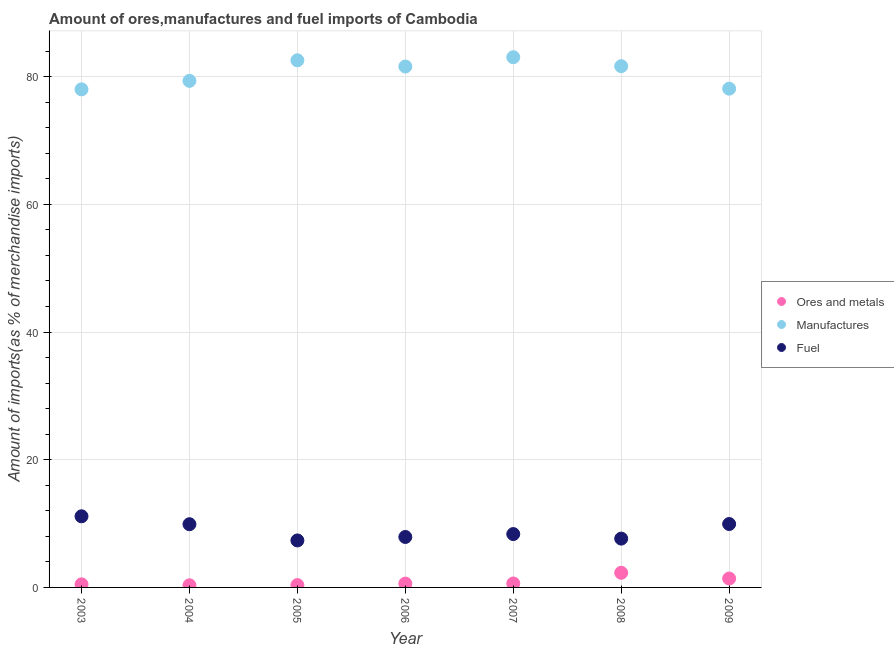How many different coloured dotlines are there?
Make the answer very short. 3. What is the percentage of fuel imports in 2005?
Your response must be concise. 7.36. Across all years, what is the maximum percentage of fuel imports?
Provide a short and direct response. 11.14. Across all years, what is the minimum percentage of manufactures imports?
Keep it short and to the point. 78.02. In which year was the percentage of manufactures imports maximum?
Provide a short and direct response. 2007. In which year was the percentage of fuel imports minimum?
Make the answer very short. 2005. What is the total percentage of fuel imports in the graph?
Your answer should be compact. 62.24. What is the difference between the percentage of ores and metals imports in 2003 and that in 2004?
Your response must be concise. 0.15. What is the difference between the percentage of manufactures imports in 2003 and the percentage of ores and metals imports in 2005?
Provide a short and direct response. 77.65. What is the average percentage of fuel imports per year?
Your answer should be compact. 8.89. In the year 2003, what is the difference between the percentage of manufactures imports and percentage of fuel imports?
Provide a short and direct response. 66.88. In how many years, is the percentage of fuel imports greater than 24 %?
Provide a short and direct response. 0. What is the ratio of the percentage of ores and metals imports in 2003 to that in 2004?
Offer a terse response. 1.44. Is the percentage of fuel imports in 2005 less than that in 2008?
Provide a succinct answer. Yes. Is the difference between the percentage of ores and metals imports in 2006 and 2007 greater than the difference between the percentage of fuel imports in 2006 and 2007?
Your response must be concise. Yes. What is the difference between the highest and the second highest percentage of manufactures imports?
Your response must be concise. 0.48. What is the difference between the highest and the lowest percentage of fuel imports?
Keep it short and to the point. 3.78. In how many years, is the percentage of manufactures imports greater than the average percentage of manufactures imports taken over all years?
Offer a terse response. 4. Is the sum of the percentage of fuel imports in 2004 and 2007 greater than the maximum percentage of ores and metals imports across all years?
Your answer should be very brief. Yes. Is it the case that in every year, the sum of the percentage of ores and metals imports and percentage of manufactures imports is greater than the percentage of fuel imports?
Give a very brief answer. Yes. Does the percentage of manufactures imports monotonically increase over the years?
Provide a short and direct response. No. Is the percentage of ores and metals imports strictly greater than the percentage of manufactures imports over the years?
Keep it short and to the point. No. Is the percentage of ores and metals imports strictly less than the percentage of fuel imports over the years?
Give a very brief answer. Yes. How many dotlines are there?
Give a very brief answer. 3. What is the difference between two consecutive major ticks on the Y-axis?
Make the answer very short. 20. Does the graph contain any zero values?
Your answer should be compact. No. How many legend labels are there?
Provide a succinct answer. 3. What is the title of the graph?
Your response must be concise. Amount of ores,manufactures and fuel imports of Cambodia. What is the label or title of the Y-axis?
Provide a succinct answer. Amount of imports(as % of merchandise imports). What is the Amount of imports(as % of merchandise imports) of Ores and metals in 2003?
Keep it short and to the point. 0.49. What is the Amount of imports(as % of merchandise imports) of Manufactures in 2003?
Your answer should be compact. 78.02. What is the Amount of imports(as % of merchandise imports) in Fuel in 2003?
Offer a terse response. 11.14. What is the Amount of imports(as % of merchandise imports) of Ores and metals in 2004?
Your response must be concise. 0.34. What is the Amount of imports(as % of merchandise imports) in Manufactures in 2004?
Offer a terse response. 79.35. What is the Amount of imports(as % of merchandise imports) of Fuel in 2004?
Ensure brevity in your answer.  9.9. What is the Amount of imports(as % of merchandise imports) of Ores and metals in 2005?
Your answer should be compact. 0.37. What is the Amount of imports(as % of merchandise imports) of Manufactures in 2005?
Offer a terse response. 82.57. What is the Amount of imports(as % of merchandise imports) of Fuel in 2005?
Provide a short and direct response. 7.36. What is the Amount of imports(as % of merchandise imports) in Ores and metals in 2006?
Offer a very short reply. 0.6. What is the Amount of imports(as % of merchandise imports) in Manufactures in 2006?
Ensure brevity in your answer.  81.6. What is the Amount of imports(as % of merchandise imports) of Fuel in 2006?
Your answer should be compact. 7.9. What is the Amount of imports(as % of merchandise imports) of Ores and metals in 2007?
Keep it short and to the point. 0.62. What is the Amount of imports(as % of merchandise imports) in Manufactures in 2007?
Provide a succinct answer. 83.05. What is the Amount of imports(as % of merchandise imports) of Fuel in 2007?
Keep it short and to the point. 8.36. What is the Amount of imports(as % of merchandise imports) of Ores and metals in 2008?
Make the answer very short. 2.29. What is the Amount of imports(as % of merchandise imports) of Manufactures in 2008?
Provide a succinct answer. 81.65. What is the Amount of imports(as % of merchandise imports) in Fuel in 2008?
Keep it short and to the point. 7.65. What is the Amount of imports(as % of merchandise imports) of Ores and metals in 2009?
Provide a short and direct response. 1.4. What is the Amount of imports(as % of merchandise imports) of Manufactures in 2009?
Your answer should be very brief. 78.13. What is the Amount of imports(as % of merchandise imports) in Fuel in 2009?
Provide a short and direct response. 9.93. Across all years, what is the maximum Amount of imports(as % of merchandise imports) of Ores and metals?
Offer a very short reply. 2.29. Across all years, what is the maximum Amount of imports(as % of merchandise imports) in Manufactures?
Your answer should be very brief. 83.05. Across all years, what is the maximum Amount of imports(as % of merchandise imports) of Fuel?
Your answer should be compact. 11.14. Across all years, what is the minimum Amount of imports(as % of merchandise imports) of Ores and metals?
Your response must be concise. 0.34. Across all years, what is the minimum Amount of imports(as % of merchandise imports) of Manufactures?
Your answer should be compact. 78.02. Across all years, what is the minimum Amount of imports(as % of merchandise imports) in Fuel?
Give a very brief answer. 7.36. What is the total Amount of imports(as % of merchandise imports) of Ores and metals in the graph?
Offer a terse response. 6.1. What is the total Amount of imports(as % of merchandise imports) in Manufactures in the graph?
Keep it short and to the point. 564.35. What is the total Amount of imports(as % of merchandise imports) in Fuel in the graph?
Offer a terse response. 62.24. What is the difference between the Amount of imports(as % of merchandise imports) in Ores and metals in 2003 and that in 2004?
Your answer should be compact. 0.15. What is the difference between the Amount of imports(as % of merchandise imports) of Manufactures in 2003 and that in 2004?
Your answer should be compact. -1.33. What is the difference between the Amount of imports(as % of merchandise imports) of Fuel in 2003 and that in 2004?
Provide a succinct answer. 1.24. What is the difference between the Amount of imports(as % of merchandise imports) in Ores and metals in 2003 and that in 2005?
Your response must be concise. 0.12. What is the difference between the Amount of imports(as % of merchandise imports) in Manufactures in 2003 and that in 2005?
Provide a succinct answer. -4.55. What is the difference between the Amount of imports(as % of merchandise imports) of Fuel in 2003 and that in 2005?
Your answer should be very brief. 3.78. What is the difference between the Amount of imports(as % of merchandise imports) of Ores and metals in 2003 and that in 2006?
Offer a very short reply. -0.12. What is the difference between the Amount of imports(as % of merchandise imports) of Manufactures in 2003 and that in 2006?
Your answer should be compact. -3.58. What is the difference between the Amount of imports(as % of merchandise imports) of Fuel in 2003 and that in 2006?
Make the answer very short. 3.24. What is the difference between the Amount of imports(as % of merchandise imports) in Ores and metals in 2003 and that in 2007?
Keep it short and to the point. -0.14. What is the difference between the Amount of imports(as % of merchandise imports) of Manufactures in 2003 and that in 2007?
Your answer should be very brief. -5.03. What is the difference between the Amount of imports(as % of merchandise imports) of Fuel in 2003 and that in 2007?
Your response must be concise. 2.78. What is the difference between the Amount of imports(as % of merchandise imports) of Ores and metals in 2003 and that in 2008?
Offer a terse response. -1.81. What is the difference between the Amount of imports(as % of merchandise imports) in Manufactures in 2003 and that in 2008?
Provide a succinct answer. -3.63. What is the difference between the Amount of imports(as % of merchandise imports) in Fuel in 2003 and that in 2008?
Offer a terse response. 3.5. What is the difference between the Amount of imports(as % of merchandise imports) in Ores and metals in 2003 and that in 2009?
Your answer should be very brief. -0.91. What is the difference between the Amount of imports(as % of merchandise imports) of Manufactures in 2003 and that in 2009?
Provide a short and direct response. -0.11. What is the difference between the Amount of imports(as % of merchandise imports) in Fuel in 2003 and that in 2009?
Your answer should be compact. 1.21. What is the difference between the Amount of imports(as % of merchandise imports) of Ores and metals in 2004 and that in 2005?
Offer a terse response. -0.03. What is the difference between the Amount of imports(as % of merchandise imports) of Manufactures in 2004 and that in 2005?
Your answer should be compact. -3.22. What is the difference between the Amount of imports(as % of merchandise imports) in Fuel in 2004 and that in 2005?
Offer a terse response. 2.54. What is the difference between the Amount of imports(as % of merchandise imports) in Ores and metals in 2004 and that in 2006?
Offer a terse response. -0.26. What is the difference between the Amount of imports(as % of merchandise imports) of Manufactures in 2004 and that in 2006?
Provide a short and direct response. -2.25. What is the difference between the Amount of imports(as % of merchandise imports) of Fuel in 2004 and that in 2006?
Make the answer very short. 2. What is the difference between the Amount of imports(as % of merchandise imports) in Ores and metals in 2004 and that in 2007?
Your response must be concise. -0.28. What is the difference between the Amount of imports(as % of merchandise imports) in Manufactures in 2004 and that in 2007?
Your answer should be compact. -3.7. What is the difference between the Amount of imports(as % of merchandise imports) of Fuel in 2004 and that in 2007?
Provide a short and direct response. 1.54. What is the difference between the Amount of imports(as % of merchandise imports) of Ores and metals in 2004 and that in 2008?
Ensure brevity in your answer.  -1.96. What is the difference between the Amount of imports(as % of merchandise imports) of Manufactures in 2004 and that in 2008?
Ensure brevity in your answer.  -2.3. What is the difference between the Amount of imports(as % of merchandise imports) of Fuel in 2004 and that in 2008?
Offer a terse response. 2.25. What is the difference between the Amount of imports(as % of merchandise imports) in Ores and metals in 2004 and that in 2009?
Your answer should be very brief. -1.06. What is the difference between the Amount of imports(as % of merchandise imports) of Manufactures in 2004 and that in 2009?
Ensure brevity in your answer.  1.22. What is the difference between the Amount of imports(as % of merchandise imports) in Fuel in 2004 and that in 2009?
Ensure brevity in your answer.  -0.03. What is the difference between the Amount of imports(as % of merchandise imports) in Ores and metals in 2005 and that in 2006?
Provide a succinct answer. -0.24. What is the difference between the Amount of imports(as % of merchandise imports) in Manufactures in 2005 and that in 2006?
Offer a terse response. 0.97. What is the difference between the Amount of imports(as % of merchandise imports) in Fuel in 2005 and that in 2006?
Offer a terse response. -0.55. What is the difference between the Amount of imports(as % of merchandise imports) of Ores and metals in 2005 and that in 2007?
Offer a very short reply. -0.25. What is the difference between the Amount of imports(as % of merchandise imports) of Manufactures in 2005 and that in 2007?
Your answer should be very brief. -0.48. What is the difference between the Amount of imports(as % of merchandise imports) of Fuel in 2005 and that in 2007?
Your answer should be very brief. -1. What is the difference between the Amount of imports(as % of merchandise imports) of Ores and metals in 2005 and that in 2008?
Your answer should be very brief. -1.93. What is the difference between the Amount of imports(as % of merchandise imports) in Manufactures in 2005 and that in 2008?
Provide a succinct answer. 0.92. What is the difference between the Amount of imports(as % of merchandise imports) in Fuel in 2005 and that in 2008?
Provide a short and direct response. -0.29. What is the difference between the Amount of imports(as % of merchandise imports) in Ores and metals in 2005 and that in 2009?
Your answer should be very brief. -1.03. What is the difference between the Amount of imports(as % of merchandise imports) in Manufactures in 2005 and that in 2009?
Ensure brevity in your answer.  4.44. What is the difference between the Amount of imports(as % of merchandise imports) of Fuel in 2005 and that in 2009?
Your answer should be very brief. -2.57. What is the difference between the Amount of imports(as % of merchandise imports) of Ores and metals in 2006 and that in 2007?
Provide a short and direct response. -0.02. What is the difference between the Amount of imports(as % of merchandise imports) in Manufactures in 2006 and that in 2007?
Your response must be concise. -1.46. What is the difference between the Amount of imports(as % of merchandise imports) of Fuel in 2006 and that in 2007?
Your answer should be compact. -0.45. What is the difference between the Amount of imports(as % of merchandise imports) in Ores and metals in 2006 and that in 2008?
Your answer should be very brief. -1.69. What is the difference between the Amount of imports(as % of merchandise imports) of Manufactures in 2006 and that in 2008?
Offer a terse response. -0.05. What is the difference between the Amount of imports(as % of merchandise imports) in Fuel in 2006 and that in 2008?
Provide a succinct answer. 0.26. What is the difference between the Amount of imports(as % of merchandise imports) of Ores and metals in 2006 and that in 2009?
Offer a very short reply. -0.8. What is the difference between the Amount of imports(as % of merchandise imports) in Manufactures in 2006 and that in 2009?
Make the answer very short. 3.47. What is the difference between the Amount of imports(as % of merchandise imports) of Fuel in 2006 and that in 2009?
Your response must be concise. -2.03. What is the difference between the Amount of imports(as % of merchandise imports) of Ores and metals in 2007 and that in 2008?
Keep it short and to the point. -1.67. What is the difference between the Amount of imports(as % of merchandise imports) of Manufactures in 2007 and that in 2008?
Provide a short and direct response. 1.4. What is the difference between the Amount of imports(as % of merchandise imports) in Fuel in 2007 and that in 2008?
Your response must be concise. 0.71. What is the difference between the Amount of imports(as % of merchandise imports) in Ores and metals in 2007 and that in 2009?
Offer a terse response. -0.78. What is the difference between the Amount of imports(as % of merchandise imports) of Manufactures in 2007 and that in 2009?
Your answer should be compact. 4.92. What is the difference between the Amount of imports(as % of merchandise imports) in Fuel in 2007 and that in 2009?
Your answer should be very brief. -1.57. What is the difference between the Amount of imports(as % of merchandise imports) in Ores and metals in 2008 and that in 2009?
Give a very brief answer. 0.89. What is the difference between the Amount of imports(as % of merchandise imports) of Manufactures in 2008 and that in 2009?
Keep it short and to the point. 3.52. What is the difference between the Amount of imports(as % of merchandise imports) of Fuel in 2008 and that in 2009?
Offer a very short reply. -2.29. What is the difference between the Amount of imports(as % of merchandise imports) of Ores and metals in 2003 and the Amount of imports(as % of merchandise imports) of Manufactures in 2004?
Offer a very short reply. -78.86. What is the difference between the Amount of imports(as % of merchandise imports) in Ores and metals in 2003 and the Amount of imports(as % of merchandise imports) in Fuel in 2004?
Your answer should be compact. -9.42. What is the difference between the Amount of imports(as % of merchandise imports) in Manufactures in 2003 and the Amount of imports(as % of merchandise imports) in Fuel in 2004?
Ensure brevity in your answer.  68.12. What is the difference between the Amount of imports(as % of merchandise imports) in Ores and metals in 2003 and the Amount of imports(as % of merchandise imports) in Manufactures in 2005?
Give a very brief answer. -82.08. What is the difference between the Amount of imports(as % of merchandise imports) of Ores and metals in 2003 and the Amount of imports(as % of merchandise imports) of Fuel in 2005?
Your answer should be compact. -6.87. What is the difference between the Amount of imports(as % of merchandise imports) of Manufactures in 2003 and the Amount of imports(as % of merchandise imports) of Fuel in 2005?
Your response must be concise. 70.66. What is the difference between the Amount of imports(as % of merchandise imports) of Ores and metals in 2003 and the Amount of imports(as % of merchandise imports) of Manufactures in 2006?
Offer a very short reply. -81.11. What is the difference between the Amount of imports(as % of merchandise imports) in Ores and metals in 2003 and the Amount of imports(as % of merchandise imports) in Fuel in 2006?
Provide a succinct answer. -7.42. What is the difference between the Amount of imports(as % of merchandise imports) of Manufactures in 2003 and the Amount of imports(as % of merchandise imports) of Fuel in 2006?
Offer a very short reply. 70.12. What is the difference between the Amount of imports(as % of merchandise imports) of Ores and metals in 2003 and the Amount of imports(as % of merchandise imports) of Manufactures in 2007?
Provide a short and direct response. -82.56. What is the difference between the Amount of imports(as % of merchandise imports) in Ores and metals in 2003 and the Amount of imports(as % of merchandise imports) in Fuel in 2007?
Give a very brief answer. -7.87. What is the difference between the Amount of imports(as % of merchandise imports) in Manufactures in 2003 and the Amount of imports(as % of merchandise imports) in Fuel in 2007?
Give a very brief answer. 69.66. What is the difference between the Amount of imports(as % of merchandise imports) in Ores and metals in 2003 and the Amount of imports(as % of merchandise imports) in Manufactures in 2008?
Give a very brief answer. -81.16. What is the difference between the Amount of imports(as % of merchandise imports) in Ores and metals in 2003 and the Amount of imports(as % of merchandise imports) in Fuel in 2008?
Your answer should be compact. -7.16. What is the difference between the Amount of imports(as % of merchandise imports) in Manufactures in 2003 and the Amount of imports(as % of merchandise imports) in Fuel in 2008?
Keep it short and to the point. 70.37. What is the difference between the Amount of imports(as % of merchandise imports) in Ores and metals in 2003 and the Amount of imports(as % of merchandise imports) in Manufactures in 2009?
Your response must be concise. -77.64. What is the difference between the Amount of imports(as % of merchandise imports) of Ores and metals in 2003 and the Amount of imports(as % of merchandise imports) of Fuel in 2009?
Make the answer very short. -9.45. What is the difference between the Amount of imports(as % of merchandise imports) in Manufactures in 2003 and the Amount of imports(as % of merchandise imports) in Fuel in 2009?
Your answer should be very brief. 68.09. What is the difference between the Amount of imports(as % of merchandise imports) in Ores and metals in 2004 and the Amount of imports(as % of merchandise imports) in Manufactures in 2005?
Offer a terse response. -82.23. What is the difference between the Amount of imports(as % of merchandise imports) of Ores and metals in 2004 and the Amount of imports(as % of merchandise imports) of Fuel in 2005?
Provide a short and direct response. -7.02. What is the difference between the Amount of imports(as % of merchandise imports) in Manufactures in 2004 and the Amount of imports(as % of merchandise imports) in Fuel in 2005?
Your response must be concise. 71.99. What is the difference between the Amount of imports(as % of merchandise imports) in Ores and metals in 2004 and the Amount of imports(as % of merchandise imports) in Manufactures in 2006?
Provide a succinct answer. -81.26. What is the difference between the Amount of imports(as % of merchandise imports) in Ores and metals in 2004 and the Amount of imports(as % of merchandise imports) in Fuel in 2006?
Your response must be concise. -7.57. What is the difference between the Amount of imports(as % of merchandise imports) of Manufactures in 2004 and the Amount of imports(as % of merchandise imports) of Fuel in 2006?
Make the answer very short. 71.44. What is the difference between the Amount of imports(as % of merchandise imports) of Ores and metals in 2004 and the Amount of imports(as % of merchandise imports) of Manufactures in 2007?
Provide a succinct answer. -82.71. What is the difference between the Amount of imports(as % of merchandise imports) in Ores and metals in 2004 and the Amount of imports(as % of merchandise imports) in Fuel in 2007?
Provide a succinct answer. -8.02. What is the difference between the Amount of imports(as % of merchandise imports) of Manufactures in 2004 and the Amount of imports(as % of merchandise imports) of Fuel in 2007?
Keep it short and to the point. 70.99. What is the difference between the Amount of imports(as % of merchandise imports) of Ores and metals in 2004 and the Amount of imports(as % of merchandise imports) of Manufactures in 2008?
Keep it short and to the point. -81.31. What is the difference between the Amount of imports(as % of merchandise imports) in Ores and metals in 2004 and the Amount of imports(as % of merchandise imports) in Fuel in 2008?
Provide a short and direct response. -7.31. What is the difference between the Amount of imports(as % of merchandise imports) in Manufactures in 2004 and the Amount of imports(as % of merchandise imports) in Fuel in 2008?
Offer a terse response. 71.7. What is the difference between the Amount of imports(as % of merchandise imports) in Ores and metals in 2004 and the Amount of imports(as % of merchandise imports) in Manufactures in 2009?
Provide a short and direct response. -77.79. What is the difference between the Amount of imports(as % of merchandise imports) in Ores and metals in 2004 and the Amount of imports(as % of merchandise imports) in Fuel in 2009?
Your response must be concise. -9.6. What is the difference between the Amount of imports(as % of merchandise imports) of Manufactures in 2004 and the Amount of imports(as % of merchandise imports) of Fuel in 2009?
Offer a terse response. 69.41. What is the difference between the Amount of imports(as % of merchandise imports) of Ores and metals in 2005 and the Amount of imports(as % of merchandise imports) of Manufactures in 2006?
Ensure brevity in your answer.  -81.23. What is the difference between the Amount of imports(as % of merchandise imports) of Ores and metals in 2005 and the Amount of imports(as % of merchandise imports) of Fuel in 2006?
Provide a short and direct response. -7.54. What is the difference between the Amount of imports(as % of merchandise imports) in Manufactures in 2005 and the Amount of imports(as % of merchandise imports) in Fuel in 2006?
Offer a very short reply. 74.66. What is the difference between the Amount of imports(as % of merchandise imports) in Ores and metals in 2005 and the Amount of imports(as % of merchandise imports) in Manufactures in 2007?
Your answer should be very brief. -82.68. What is the difference between the Amount of imports(as % of merchandise imports) of Ores and metals in 2005 and the Amount of imports(as % of merchandise imports) of Fuel in 2007?
Your response must be concise. -7.99. What is the difference between the Amount of imports(as % of merchandise imports) of Manufactures in 2005 and the Amount of imports(as % of merchandise imports) of Fuel in 2007?
Your answer should be very brief. 74.21. What is the difference between the Amount of imports(as % of merchandise imports) of Ores and metals in 2005 and the Amount of imports(as % of merchandise imports) of Manufactures in 2008?
Offer a very short reply. -81.28. What is the difference between the Amount of imports(as % of merchandise imports) of Ores and metals in 2005 and the Amount of imports(as % of merchandise imports) of Fuel in 2008?
Provide a succinct answer. -7.28. What is the difference between the Amount of imports(as % of merchandise imports) in Manufactures in 2005 and the Amount of imports(as % of merchandise imports) in Fuel in 2008?
Offer a terse response. 74.92. What is the difference between the Amount of imports(as % of merchandise imports) in Ores and metals in 2005 and the Amount of imports(as % of merchandise imports) in Manufactures in 2009?
Your answer should be compact. -77.76. What is the difference between the Amount of imports(as % of merchandise imports) in Ores and metals in 2005 and the Amount of imports(as % of merchandise imports) in Fuel in 2009?
Your answer should be compact. -9.57. What is the difference between the Amount of imports(as % of merchandise imports) of Manufactures in 2005 and the Amount of imports(as % of merchandise imports) of Fuel in 2009?
Your answer should be very brief. 72.63. What is the difference between the Amount of imports(as % of merchandise imports) of Ores and metals in 2006 and the Amount of imports(as % of merchandise imports) of Manufactures in 2007?
Your answer should be very brief. -82.45. What is the difference between the Amount of imports(as % of merchandise imports) in Ores and metals in 2006 and the Amount of imports(as % of merchandise imports) in Fuel in 2007?
Keep it short and to the point. -7.76. What is the difference between the Amount of imports(as % of merchandise imports) of Manufactures in 2006 and the Amount of imports(as % of merchandise imports) of Fuel in 2007?
Your answer should be very brief. 73.24. What is the difference between the Amount of imports(as % of merchandise imports) of Ores and metals in 2006 and the Amount of imports(as % of merchandise imports) of Manufactures in 2008?
Make the answer very short. -81.05. What is the difference between the Amount of imports(as % of merchandise imports) in Ores and metals in 2006 and the Amount of imports(as % of merchandise imports) in Fuel in 2008?
Keep it short and to the point. -7.05. What is the difference between the Amount of imports(as % of merchandise imports) of Manufactures in 2006 and the Amount of imports(as % of merchandise imports) of Fuel in 2008?
Offer a terse response. 73.95. What is the difference between the Amount of imports(as % of merchandise imports) of Ores and metals in 2006 and the Amount of imports(as % of merchandise imports) of Manufactures in 2009?
Your answer should be compact. -77.52. What is the difference between the Amount of imports(as % of merchandise imports) in Ores and metals in 2006 and the Amount of imports(as % of merchandise imports) in Fuel in 2009?
Keep it short and to the point. -9.33. What is the difference between the Amount of imports(as % of merchandise imports) in Manufactures in 2006 and the Amount of imports(as % of merchandise imports) in Fuel in 2009?
Keep it short and to the point. 71.66. What is the difference between the Amount of imports(as % of merchandise imports) of Ores and metals in 2007 and the Amount of imports(as % of merchandise imports) of Manufactures in 2008?
Give a very brief answer. -81.03. What is the difference between the Amount of imports(as % of merchandise imports) of Ores and metals in 2007 and the Amount of imports(as % of merchandise imports) of Fuel in 2008?
Give a very brief answer. -7.03. What is the difference between the Amount of imports(as % of merchandise imports) of Manufactures in 2007 and the Amount of imports(as % of merchandise imports) of Fuel in 2008?
Keep it short and to the point. 75.4. What is the difference between the Amount of imports(as % of merchandise imports) of Ores and metals in 2007 and the Amount of imports(as % of merchandise imports) of Manufactures in 2009?
Offer a terse response. -77.51. What is the difference between the Amount of imports(as % of merchandise imports) in Ores and metals in 2007 and the Amount of imports(as % of merchandise imports) in Fuel in 2009?
Offer a very short reply. -9.31. What is the difference between the Amount of imports(as % of merchandise imports) of Manufactures in 2007 and the Amount of imports(as % of merchandise imports) of Fuel in 2009?
Provide a succinct answer. 73.12. What is the difference between the Amount of imports(as % of merchandise imports) in Ores and metals in 2008 and the Amount of imports(as % of merchandise imports) in Manufactures in 2009?
Give a very brief answer. -75.83. What is the difference between the Amount of imports(as % of merchandise imports) in Ores and metals in 2008 and the Amount of imports(as % of merchandise imports) in Fuel in 2009?
Give a very brief answer. -7.64. What is the difference between the Amount of imports(as % of merchandise imports) of Manufactures in 2008 and the Amount of imports(as % of merchandise imports) of Fuel in 2009?
Keep it short and to the point. 71.72. What is the average Amount of imports(as % of merchandise imports) in Ores and metals per year?
Give a very brief answer. 0.87. What is the average Amount of imports(as % of merchandise imports) of Manufactures per year?
Keep it short and to the point. 80.62. What is the average Amount of imports(as % of merchandise imports) of Fuel per year?
Provide a succinct answer. 8.89. In the year 2003, what is the difference between the Amount of imports(as % of merchandise imports) in Ores and metals and Amount of imports(as % of merchandise imports) in Manufactures?
Provide a short and direct response. -77.53. In the year 2003, what is the difference between the Amount of imports(as % of merchandise imports) of Ores and metals and Amount of imports(as % of merchandise imports) of Fuel?
Offer a terse response. -10.66. In the year 2003, what is the difference between the Amount of imports(as % of merchandise imports) of Manufactures and Amount of imports(as % of merchandise imports) of Fuel?
Your answer should be very brief. 66.88. In the year 2004, what is the difference between the Amount of imports(as % of merchandise imports) of Ores and metals and Amount of imports(as % of merchandise imports) of Manufactures?
Offer a very short reply. -79.01. In the year 2004, what is the difference between the Amount of imports(as % of merchandise imports) in Ores and metals and Amount of imports(as % of merchandise imports) in Fuel?
Your response must be concise. -9.56. In the year 2004, what is the difference between the Amount of imports(as % of merchandise imports) in Manufactures and Amount of imports(as % of merchandise imports) in Fuel?
Give a very brief answer. 69.45. In the year 2005, what is the difference between the Amount of imports(as % of merchandise imports) in Ores and metals and Amount of imports(as % of merchandise imports) in Manufactures?
Your answer should be very brief. -82.2. In the year 2005, what is the difference between the Amount of imports(as % of merchandise imports) in Ores and metals and Amount of imports(as % of merchandise imports) in Fuel?
Provide a succinct answer. -6.99. In the year 2005, what is the difference between the Amount of imports(as % of merchandise imports) in Manufactures and Amount of imports(as % of merchandise imports) in Fuel?
Provide a succinct answer. 75.21. In the year 2006, what is the difference between the Amount of imports(as % of merchandise imports) of Ores and metals and Amount of imports(as % of merchandise imports) of Manufactures?
Offer a terse response. -80.99. In the year 2006, what is the difference between the Amount of imports(as % of merchandise imports) in Ores and metals and Amount of imports(as % of merchandise imports) in Fuel?
Give a very brief answer. -7.3. In the year 2006, what is the difference between the Amount of imports(as % of merchandise imports) of Manufactures and Amount of imports(as % of merchandise imports) of Fuel?
Keep it short and to the point. 73.69. In the year 2007, what is the difference between the Amount of imports(as % of merchandise imports) in Ores and metals and Amount of imports(as % of merchandise imports) in Manufactures?
Provide a short and direct response. -82.43. In the year 2007, what is the difference between the Amount of imports(as % of merchandise imports) in Ores and metals and Amount of imports(as % of merchandise imports) in Fuel?
Offer a terse response. -7.74. In the year 2007, what is the difference between the Amount of imports(as % of merchandise imports) in Manufactures and Amount of imports(as % of merchandise imports) in Fuel?
Your answer should be very brief. 74.69. In the year 2008, what is the difference between the Amount of imports(as % of merchandise imports) in Ores and metals and Amount of imports(as % of merchandise imports) in Manufactures?
Your answer should be very brief. -79.36. In the year 2008, what is the difference between the Amount of imports(as % of merchandise imports) of Ores and metals and Amount of imports(as % of merchandise imports) of Fuel?
Offer a terse response. -5.35. In the year 2008, what is the difference between the Amount of imports(as % of merchandise imports) in Manufactures and Amount of imports(as % of merchandise imports) in Fuel?
Your response must be concise. 74. In the year 2009, what is the difference between the Amount of imports(as % of merchandise imports) of Ores and metals and Amount of imports(as % of merchandise imports) of Manufactures?
Your response must be concise. -76.73. In the year 2009, what is the difference between the Amount of imports(as % of merchandise imports) of Ores and metals and Amount of imports(as % of merchandise imports) of Fuel?
Your response must be concise. -8.53. In the year 2009, what is the difference between the Amount of imports(as % of merchandise imports) in Manufactures and Amount of imports(as % of merchandise imports) in Fuel?
Your answer should be compact. 68.19. What is the ratio of the Amount of imports(as % of merchandise imports) of Ores and metals in 2003 to that in 2004?
Make the answer very short. 1.44. What is the ratio of the Amount of imports(as % of merchandise imports) of Manufactures in 2003 to that in 2004?
Offer a terse response. 0.98. What is the ratio of the Amount of imports(as % of merchandise imports) of Fuel in 2003 to that in 2004?
Keep it short and to the point. 1.13. What is the ratio of the Amount of imports(as % of merchandise imports) in Ores and metals in 2003 to that in 2005?
Keep it short and to the point. 1.33. What is the ratio of the Amount of imports(as % of merchandise imports) of Manufactures in 2003 to that in 2005?
Your answer should be very brief. 0.94. What is the ratio of the Amount of imports(as % of merchandise imports) in Fuel in 2003 to that in 2005?
Your response must be concise. 1.51. What is the ratio of the Amount of imports(as % of merchandise imports) of Ores and metals in 2003 to that in 2006?
Your answer should be very brief. 0.81. What is the ratio of the Amount of imports(as % of merchandise imports) in Manufactures in 2003 to that in 2006?
Your answer should be very brief. 0.96. What is the ratio of the Amount of imports(as % of merchandise imports) in Fuel in 2003 to that in 2006?
Offer a terse response. 1.41. What is the ratio of the Amount of imports(as % of merchandise imports) in Ores and metals in 2003 to that in 2007?
Give a very brief answer. 0.78. What is the ratio of the Amount of imports(as % of merchandise imports) in Manufactures in 2003 to that in 2007?
Make the answer very short. 0.94. What is the ratio of the Amount of imports(as % of merchandise imports) of Fuel in 2003 to that in 2007?
Provide a succinct answer. 1.33. What is the ratio of the Amount of imports(as % of merchandise imports) in Ores and metals in 2003 to that in 2008?
Make the answer very short. 0.21. What is the ratio of the Amount of imports(as % of merchandise imports) in Manufactures in 2003 to that in 2008?
Provide a short and direct response. 0.96. What is the ratio of the Amount of imports(as % of merchandise imports) in Fuel in 2003 to that in 2008?
Keep it short and to the point. 1.46. What is the ratio of the Amount of imports(as % of merchandise imports) of Ores and metals in 2003 to that in 2009?
Your answer should be very brief. 0.35. What is the ratio of the Amount of imports(as % of merchandise imports) of Fuel in 2003 to that in 2009?
Give a very brief answer. 1.12. What is the ratio of the Amount of imports(as % of merchandise imports) of Ores and metals in 2004 to that in 2005?
Keep it short and to the point. 0.92. What is the ratio of the Amount of imports(as % of merchandise imports) of Fuel in 2004 to that in 2005?
Make the answer very short. 1.35. What is the ratio of the Amount of imports(as % of merchandise imports) of Ores and metals in 2004 to that in 2006?
Provide a succinct answer. 0.56. What is the ratio of the Amount of imports(as % of merchandise imports) in Manufactures in 2004 to that in 2006?
Offer a very short reply. 0.97. What is the ratio of the Amount of imports(as % of merchandise imports) of Fuel in 2004 to that in 2006?
Give a very brief answer. 1.25. What is the ratio of the Amount of imports(as % of merchandise imports) in Ores and metals in 2004 to that in 2007?
Give a very brief answer. 0.54. What is the ratio of the Amount of imports(as % of merchandise imports) of Manufactures in 2004 to that in 2007?
Your answer should be very brief. 0.96. What is the ratio of the Amount of imports(as % of merchandise imports) of Fuel in 2004 to that in 2007?
Make the answer very short. 1.18. What is the ratio of the Amount of imports(as % of merchandise imports) of Ores and metals in 2004 to that in 2008?
Provide a short and direct response. 0.15. What is the ratio of the Amount of imports(as % of merchandise imports) of Manufactures in 2004 to that in 2008?
Your answer should be compact. 0.97. What is the ratio of the Amount of imports(as % of merchandise imports) of Fuel in 2004 to that in 2008?
Provide a succinct answer. 1.29. What is the ratio of the Amount of imports(as % of merchandise imports) in Ores and metals in 2004 to that in 2009?
Your response must be concise. 0.24. What is the ratio of the Amount of imports(as % of merchandise imports) of Manufactures in 2004 to that in 2009?
Give a very brief answer. 1.02. What is the ratio of the Amount of imports(as % of merchandise imports) of Ores and metals in 2005 to that in 2006?
Your answer should be compact. 0.61. What is the ratio of the Amount of imports(as % of merchandise imports) in Manufactures in 2005 to that in 2006?
Your answer should be very brief. 1.01. What is the ratio of the Amount of imports(as % of merchandise imports) in Ores and metals in 2005 to that in 2007?
Ensure brevity in your answer.  0.59. What is the ratio of the Amount of imports(as % of merchandise imports) of Fuel in 2005 to that in 2007?
Make the answer very short. 0.88. What is the ratio of the Amount of imports(as % of merchandise imports) in Ores and metals in 2005 to that in 2008?
Offer a very short reply. 0.16. What is the ratio of the Amount of imports(as % of merchandise imports) in Manufactures in 2005 to that in 2008?
Keep it short and to the point. 1.01. What is the ratio of the Amount of imports(as % of merchandise imports) of Fuel in 2005 to that in 2008?
Your answer should be very brief. 0.96. What is the ratio of the Amount of imports(as % of merchandise imports) of Ores and metals in 2005 to that in 2009?
Your answer should be compact. 0.26. What is the ratio of the Amount of imports(as % of merchandise imports) of Manufactures in 2005 to that in 2009?
Ensure brevity in your answer.  1.06. What is the ratio of the Amount of imports(as % of merchandise imports) of Fuel in 2005 to that in 2009?
Offer a terse response. 0.74. What is the ratio of the Amount of imports(as % of merchandise imports) in Ores and metals in 2006 to that in 2007?
Your response must be concise. 0.97. What is the ratio of the Amount of imports(as % of merchandise imports) of Manufactures in 2006 to that in 2007?
Your answer should be compact. 0.98. What is the ratio of the Amount of imports(as % of merchandise imports) of Fuel in 2006 to that in 2007?
Your answer should be compact. 0.95. What is the ratio of the Amount of imports(as % of merchandise imports) in Ores and metals in 2006 to that in 2008?
Provide a succinct answer. 0.26. What is the ratio of the Amount of imports(as % of merchandise imports) in Manufactures in 2006 to that in 2008?
Provide a short and direct response. 1. What is the ratio of the Amount of imports(as % of merchandise imports) of Fuel in 2006 to that in 2008?
Your answer should be very brief. 1.03. What is the ratio of the Amount of imports(as % of merchandise imports) in Ores and metals in 2006 to that in 2009?
Your answer should be compact. 0.43. What is the ratio of the Amount of imports(as % of merchandise imports) in Manufactures in 2006 to that in 2009?
Provide a short and direct response. 1.04. What is the ratio of the Amount of imports(as % of merchandise imports) of Fuel in 2006 to that in 2009?
Provide a succinct answer. 0.8. What is the ratio of the Amount of imports(as % of merchandise imports) of Ores and metals in 2007 to that in 2008?
Your answer should be compact. 0.27. What is the ratio of the Amount of imports(as % of merchandise imports) of Manufactures in 2007 to that in 2008?
Your answer should be compact. 1.02. What is the ratio of the Amount of imports(as % of merchandise imports) of Fuel in 2007 to that in 2008?
Offer a very short reply. 1.09. What is the ratio of the Amount of imports(as % of merchandise imports) in Ores and metals in 2007 to that in 2009?
Your response must be concise. 0.44. What is the ratio of the Amount of imports(as % of merchandise imports) of Manufactures in 2007 to that in 2009?
Ensure brevity in your answer.  1.06. What is the ratio of the Amount of imports(as % of merchandise imports) in Fuel in 2007 to that in 2009?
Provide a short and direct response. 0.84. What is the ratio of the Amount of imports(as % of merchandise imports) of Ores and metals in 2008 to that in 2009?
Your response must be concise. 1.64. What is the ratio of the Amount of imports(as % of merchandise imports) in Manufactures in 2008 to that in 2009?
Your answer should be very brief. 1.05. What is the ratio of the Amount of imports(as % of merchandise imports) of Fuel in 2008 to that in 2009?
Your answer should be very brief. 0.77. What is the difference between the highest and the second highest Amount of imports(as % of merchandise imports) in Ores and metals?
Make the answer very short. 0.89. What is the difference between the highest and the second highest Amount of imports(as % of merchandise imports) of Manufactures?
Your response must be concise. 0.48. What is the difference between the highest and the second highest Amount of imports(as % of merchandise imports) in Fuel?
Your answer should be very brief. 1.21. What is the difference between the highest and the lowest Amount of imports(as % of merchandise imports) of Ores and metals?
Offer a very short reply. 1.96. What is the difference between the highest and the lowest Amount of imports(as % of merchandise imports) in Manufactures?
Make the answer very short. 5.03. What is the difference between the highest and the lowest Amount of imports(as % of merchandise imports) of Fuel?
Provide a short and direct response. 3.78. 